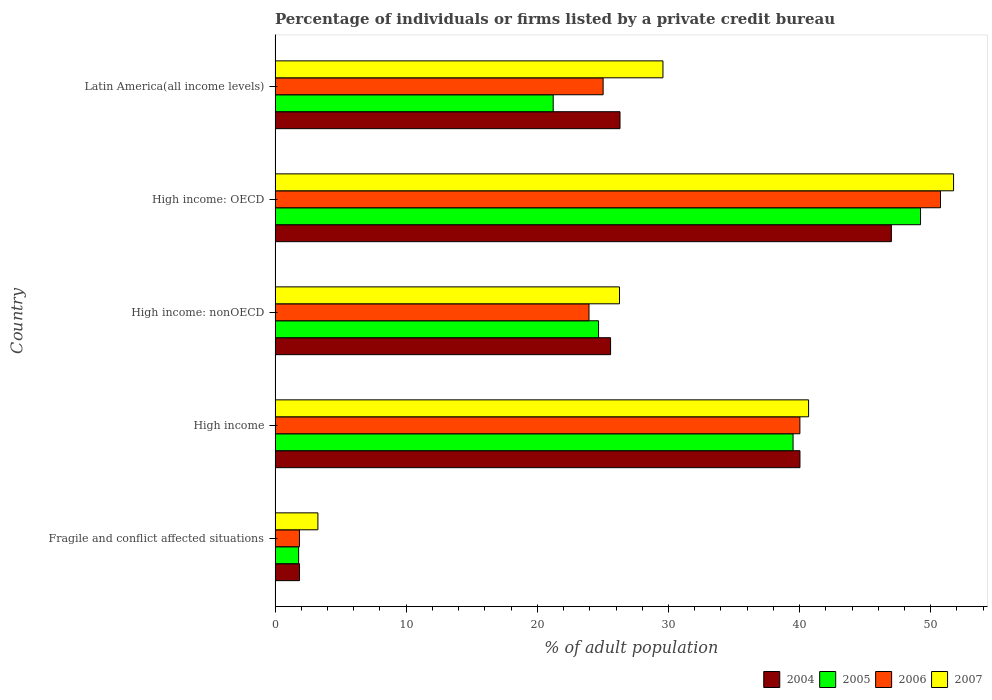What is the label of the 2nd group of bars from the top?
Make the answer very short. High income: OECD. In how many cases, is the number of bars for a given country not equal to the number of legend labels?
Keep it short and to the point. 0. What is the percentage of population listed by a private credit bureau in 2005 in Latin America(all income levels)?
Your answer should be compact. 21.21. Across all countries, what is the maximum percentage of population listed by a private credit bureau in 2006?
Offer a terse response. 50.75. Across all countries, what is the minimum percentage of population listed by a private credit bureau in 2004?
Your answer should be compact. 1.86. In which country was the percentage of population listed by a private credit bureau in 2004 maximum?
Ensure brevity in your answer.  High income: OECD. In which country was the percentage of population listed by a private credit bureau in 2006 minimum?
Give a very brief answer. Fragile and conflict affected situations. What is the total percentage of population listed by a private credit bureau in 2007 in the graph?
Offer a very short reply. 151.54. What is the difference between the percentage of population listed by a private credit bureau in 2005 in High income and that in High income: nonOECD?
Your answer should be very brief. 14.84. What is the difference between the percentage of population listed by a private credit bureau in 2004 in Latin America(all income levels) and the percentage of population listed by a private credit bureau in 2005 in High income: OECD?
Provide a succinct answer. -22.92. What is the average percentage of population listed by a private credit bureau in 2007 per country?
Make the answer very short. 30.31. What is the difference between the percentage of population listed by a private credit bureau in 2004 and percentage of population listed by a private credit bureau in 2005 in High income?
Give a very brief answer. 0.52. What is the ratio of the percentage of population listed by a private credit bureau in 2006 in High income: nonOECD to that in Latin America(all income levels)?
Your response must be concise. 0.96. Is the percentage of population listed by a private credit bureau in 2007 in Fragile and conflict affected situations less than that in High income: OECD?
Your answer should be compact. Yes. Is the difference between the percentage of population listed by a private credit bureau in 2004 in Fragile and conflict affected situations and Latin America(all income levels) greater than the difference between the percentage of population listed by a private credit bureau in 2005 in Fragile and conflict affected situations and Latin America(all income levels)?
Your answer should be very brief. No. What is the difference between the highest and the second highest percentage of population listed by a private credit bureau in 2005?
Keep it short and to the point. 9.72. What is the difference between the highest and the lowest percentage of population listed by a private credit bureau in 2004?
Provide a succinct answer. 45.14. In how many countries, is the percentage of population listed by a private credit bureau in 2005 greater than the average percentage of population listed by a private credit bureau in 2005 taken over all countries?
Ensure brevity in your answer.  2. Is the sum of the percentage of population listed by a private credit bureau in 2005 in High income: OECD and High income: nonOECD greater than the maximum percentage of population listed by a private credit bureau in 2007 across all countries?
Your response must be concise. Yes. Is it the case that in every country, the sum of the percentage of population listed by a private credit bureau in 2004 and percentage of population listed by a private credit bureau in 2005 is greater than the sum of percentage of population listed by a private credit bureau in 2006 and percentage of population listed by a private credit bureau in 2007?
Offer a terse response. No. What does the 3rd bar from the top in High income: OECD represents?
Your response must be concise. 2005. What does the 4th bar from the bottom in Latin America(all income levels) represents?
Provide a short and direct response. 2007. Are all the bars in the graph horizontal?
Your response must be concise. Yes. Does the graph contain any zero values?
Your answer should be compact. No. Does the graph contain grids?
Your answer should be compact. No. What is the title of the graph?
Your answer should be compact. Percentage of individuals or firms listed by a private credit bureau. Does "1998" appear as one of the legend labels in the graph?
Your answer should be very brief. No. What is the label or title of the X-axis?
Keep it short and to the point. % of adult population. What is the label or title of the Y-axis?
Offer a terse response. Country. What is the % of adult population in 2004 in Fragile and conflict affected situations?
Give a very brief answer. 1.86. What is the % of adult population in 2005 in Fragile and conflict affected situations?
Your answer should be compact. 1.8. What is the % of adult population in 2006 in Fragile and conflict affected situations?
Keep it short and to the point. 1.86. What is the % of adult population in 2007 in Fragile and conflict affected situations?
Offer a very short reply. 3.27. What is the % of adult population in 2004 in High income?
Make the answer very short. 40.03. What is the % of adult population of 2005 in High income?
Make the answer very short. 39.5. What is the % of adult population in 2006 in High income?
Keep it short and to the point. 40.02. What is the % of adult population of 2007 in High income?
Your answer should be compact. 40.69. What is the % of adult population in 2004 in High income: nonOECD?
Make the answer very short. 25.59. What is the % of adult population of 2005 in High income: nonOECD?
Make the answer very short. 24.67. What is the % of adult population of 2006 in High income: nonOECD?
Offer a terse response. 23.94. What is the % of adult population in 2007 in High income: nonOECD?
Offer a very short reply. 26.27. What is the % of adult population of 2005 in High income: OECD?
Provide a short and direct response. 49.22. What is the % of adult population in 2006 in High income: OECD?
Your response must be concise. 50.75. What is the % of adult population of 2007 in High income: OECD?
Your answer should be very brief. 51.74. What is the % of adult population in 2004 in Latin America(all income levels)?
Ensure brevity in your answer.  26.3. What is the % of adult population in 2005 in Latin America(all income levels)?
Make the answer very short. 21.21. What is the % of adult population of 2006 in Latin America(all income levels)?
Your answer should be very brief. 25.02. What is the % of adult population of 2007 in Latin America(all income levels)?
Offer a very short reply. 29.58. Across all countries, what is the maximum % of adult population of 2005?
Keep it short and to the point. 49.22. Across all countries, what is the maximum % of adult population in 2006?
Provide a short and direct response. 50.75. Across all countries, what is the maximum % of adult population in 2007?
Your answer should be compact. 51.74. Across all countries, what is the minimum % of adult population of 2004?
Provide a short and direct response. 1.86. Across all countries, what is the minimum % of adult population of 2005?
Offer a terse response. 1.8. Across all countries, what is the minimum % of adult population in 2006?
Your answer should be very brief. 1.86. Across all countries, what is the minimum % of adult population of 2007?
Your answer should be compact. 3.27. What is the total % of adult population in 2004 in the graph?
Offer a very short reply. 140.78. What is the total % of adult population in 2005 in the graph?
Keep it short and to the point. 136.4. What is the total % of adult population of 2006 in the graph?
Provide a short and direct response. 141.59. What is the total % of adult population of 2007 in the graph?
Keep it short and to the point. 151.54. What is the difference between the % of adult population in 2004 in Fragile and conflict affected situations and that in High income?
Your answer should be very brief. -38.16. What is the difference between the % of adult population in 2005 in Fragile and conflict affected situations and that in High income?
Provide a succinct answer. -37.71. What is the difference between the % of adult population in 2006 in Fragile and conflict affected situations and that in High income?
Offer a terse response. -38.17. What is the difference between the % of adult population in 2007 in Fragile and conflict affected situations and that in High income?
Offer a terse response. -37.42. What is the difference between the % of adult population of 2004 in Fragile and conflict affected situations and that in High income: nonOECD?
Your answer should be very brief. -23.72. What is the difference between the % of adult population of 2005 in Fragile and conflict affected situations and that in High income: nonOECD?
Your response must be concise. -22.87. What is the difference between the % of adult population of 2006 in Fragile and conflict affected situations and that in High income: nonOECD?
Offer a very short reply. -22.08. What is the difference between the % of adult population in 2007 in Fragile and conflict affected situations and that in High income: nonOECD?
Give a very brief answer. -23. What is the difference between the % of adult population in 2004 in Fragile and conflict affected situations and that in High income: OECD?
Your answer should be compact. -45.14. What is the difference between the % of adult population of 2005 in Fragile and conflict affected situations and that in High income: OECD?
Provide a short and direct response. -47.43. What is the difference between the % of adult population in 2006 in Fragile and conflict affected situations and that in High income: OECD?
Provide a short and direct response. -48.89. What is the difference between the % of adult population in 2007 in Fragile and conflict affected situations and that in High income: OECD?
Your answer should be compact. -48.48. What is the difference between the % of adult population of 2004 in Fragile and conflict affected situations and that in Latin America(all income levels)?
Provide a succinct answer. -24.44. What is the difference between the % of adult population in 2005 in Fragile and conflict affected situations and that in Latin America(all income levels)?
Your response must be concise. -19.41. What is the difference between the % of adult population of 2006 in Fragile and conflict affected situations and that in Latin America(all income levels)?
Offer a very short reply. -23.16. What is the difference between the % of adult population of 2007 in Fragile and conflict affected situations and that in Latin America(all income levels)?
Keep it short and to the point. -26.31. What is the difference between the % of adult population in 2004 in High income and that in High income: nonOECD?
Provide a short and direct response. 14.44. What is the difference between the % of adult population in 2005 in High income and that in High income: nonOECD?
Your answer should be very brief. 14.84. What is the difference between the % of adult population in 2006 in High income and that in High income: nonOECD?
Make the answer very short. 16.08. What is the difference between the % of adult population in 2007 in High income and that in High income: nonOECD?
Ensure brevity in your answer.  14.42. What is the difference between the % of adult population of 2004 in High income and that in High income: OECD?
Provide a short and direct response. -6.97. What is the difference between the % of adult population of 2005 in High income and that in High income: OECD?
Ensure brevity in your answer.  -9.72. What is the difference between the % of adult population in 2006 in High income and that in High income: OECD?
Give a very brief answer. -10.72. What is the difference between the % of adult population of 2007 in High income and that in High income: OECD?
Provide a succinct answer. -11.06. What is the difference between the % of adult population in 2004 in High income and that in Latin America(all income levels)?
Your answer should be compact. 13.72. What is the difference between the % of adult population of 2005 in High income and that in Latin America(all income levels)?
Your answer should be very brief. 18.29. What is the difference between the % of adult population of 2006 in High income and that in Latin America(all income levels)?
Ensure brevity in your answer.  15.01. What is the difference between the % of adult population in 2007 in High income and that in Latin America(all income levels)?
Your answer should be very brief. 11.11. What is the difference between the % of adult population in 2004 in High income: nonOECD and that in High income: OECD?
Make the answer very short. -21.41. What is the difference between the % of adult population in 2005 in High income: nonOECD and that in High income: OECD?
Provide a short and direct response. -24.56. What is the difference between the % of adult population of 2006 in High income: nonOECD and that in High income: OECD?
Make the answer very short. -26.81. What is the difference between the % of adult population of 2007 in High income: nonOECD and that in High income: OECD?
Your answer should be very brief. -25.48. What is the difference between the % of adult population in 2004 in High income: nonOECD and that in Latin America(all income levels)?
Your answer should be very brief. -0.72. What is the difference between the % of adult population in 2005 in High income: nonOECD and that in Latin America(all income levels)?
Offer a terse response. 3.46. What is the difference between the % of adult population of 2006 in High income: nonOECD and that in Latin America(all income levels)?
Give a very brief answer. -1.08. What is the difference between the % of adult population in 2007 in High income: nonOECD and that in Latin America(all income levels)?
Make the answer very short. -3.31. What is the difference between the % of adult population of 2004 in High income: OECD and that in Latin America(all income levels)?
Make the answer very short. 20.7. What is the difference between the % of adult population of 2005 in High income: OECD and that in Latin America(all income levels)?
Give a very brief answer. 28.01. What is the difference between the % of adult population in 2006 in High income: OECD and that in Latin America(all income levels)?
Provide a succinct answer. 25.73. What is the difference between the % of adult population of 2007 in High income: OECD and that in Latin America(all income levels)?
Your answer should be very brief. 22.16. What is the difference between the % of adult population of 2004 in Fragile and conflict affected situations and the % of adult population of 2005 in High income?
Your response must be concise. -37.64. What is the difference between the % of adult population in 2004 in Fragile and conflict affected situations and the % of adult population in 2006 in High income?
Keep it short and to the point. -38.16. What is the difference between the % of adult population in 2004 in Fragile and conflict affected situations and the % of adult population in 2007 in High income?
Your answer should be very brief. -38.82. What is the difference between the % of adult population of 2005 in Fragile and conflict affected situations and the % of adult population of 2006 in High income?
Keep it short and to the point. -38.23. What is the difference between the % of adult population in 2005 in Fragile and conflict affected situations and the % of adult population in 2007 in High income?
Provide a short and direct response. -38.89. What is the difference between the % of adult population in 2006 in Fragile and conflict affected situations and the % of adult population in 2007 in High income?
Your answer should be very brief. -38.83. What is the difference between the % of adult population in 2004 in Fragile and conflict affected situations and the % of adult population in 2005 in High income: nonOECD?
Your answer should be compact. -22.8. What is the difference between the % of adult population in 2004 in Fragile and conflict affected situations and the % of adult population in 2006 in High income: nonOECD?
Make the answer very short. -22.08. What is the difference between the % of adult population in 2004 in Fragile and conflict affected situations and the % of adult population in 2007 in High income: nonOECD?
Your answer should be very brief. -24.4. What is the difference between the % of adult population in 2005 in Fragile and conflict affected situations and the % of adult population in 2006 in High income: nonOECD?
Provide a succinct answer. -22.14. What is the difference between the % of adult population of 2005 in Fragile and conflict affected situations and the % of adult population of 2007 in High income: nonOECD?
Make the answer very short. -24.47. What is the difference between the % of adult population of 2006 in Fragile and conflict affected situations and the % of adult population of 2007 in High income: nonOECD?
Keep it short and to the point. -24.41. What is the difference between the % of adult population in 2004 in Fragile and conflict affected situations and the % of adult population in 2005 in High income: OECD?
Keep it short and to the point. -47.36. What is the difference between the % of adult population of 2004 in Fragile and conflict affected situations and the % of adult population of 2006 in High income: OECD?
Provide a succinct answer. -48.88. What is the difference between the % of adult population of 2004 in Fragile and conflict affected situations and the % of adult population of 2007 in High income: OECD?
Your response must be concise. -49.88. What is the difference between the % of adult population of 2005 in Fragile and conflict affected situations and the % of adult population of 2006 in High income: OECD?
Offer a very short reply. -48.95. What is the difference between the % of adult population of 2005 in Fragile and conflict affected situations and the % of adult population of 2007 in High income: OECD?
Provide a succinct answer. -49.95. What is the difference between the % of adult population in 2006 in Fragile and conflict affected situations and the % of adult population in 2007 in High income: OECD?
Your answer should be very brief. -49.88. What is the difference between the % of adult population in 2004 in Fragile and conflict affected situations and the % of adult population in 2005 in Latin America(all income levels)?
Provide a short and direct response. -19.35. What is the difference between the % of adult population in 2004 in Fragile and conflict affected situations and the % of adult population in 2006 in Latin America(all income levels)?
Your answer should be very brief. -23.15. What is the difference between the % of adult population of 2004 in Fragile and conflict affected situations and the % of adult population of 2007 in Latin America(all income levels)?
Offer a terse response. -27.72. What is the difference between the % of adult population in 2005 in Fragile and conflict affected situations and the % of adult population in 2006 in Latin America(all income levels)?
Ensure brevity in your answer.  -23.22. What is the difference between the % of adult population in 2005 in Fragile and conflict affected situations and the % of adult population in 2007 in Latin America(all income levels)?
Ensure brevity in your answer.  -27.78. What is the difference between the % of adult population of 2006 in Fragile and conflict affected situations and the % of adult population of 2007 in Latin America(all income levels)?
Keep it short and to the point. -27.72. What is the difference between the % of adult population in 2004 in High income and the % of adult population in 2005 in High income: nonOECD?
Keep it short and to the point. 15.36. What is the difference between the % of adult population in 2004 in High income and the % of adult population in 2006 in High income: nonOECD?
Your response must be concise. 16.09. What is the difference between the % of adult population of 2004 in High income and the % of adult population of 2007 in High income: nonOECD?
Keep it short and to the point. 13.76. What is the difference between the % of adult population of 2005 in High income and the % of adult population of 2006 in High income: nonOECD?
Make the answer very short. 15.56. What is the difference between the % of adult population in 2005 in High income and the % of adult population in 2007 in High income: nonOECD?
Provide a short and direct response. 13.24. What is the difference between the % of adult population of 2006 in High income and the % of adult population of 2007 in High income: nonOECD?
Provide a succinct answer. 13.76. What is the difference between the % of adult population of 2004 in High income and the % of adult population of 2005 in High income: OECD?
Provide a succinct answer. -9.2. What is the difference between the % of adult population of 2004 in High income and the % of adult population of 2006 in High income: OECD?
Make the answer very short. -10.72. What is the difference between the % of adult population of 2004 in High income and the % of adult population of 2007 in High income: OECD?
Provide a succinct answer. -11.72. What is the difference between the % of adult population of 2005 in High income and the % of adult population of 2006 in High income: OECD?
Provide a short and direct response. -11.24. What is the difference between the % of adult population of 2005 in High income and the % of adult population of 2007 in High income: OECD?
Provide a succinct answer. -12.24. What is the difference between the % of adult population in 2006 in High income and the % of adult population in 2007 in High income: OECD?
Provide a succinct answer. -11.72. What is the difference between the % of adult population in 2004 in High income and the % of adult population in 2005 in Latin America(all income levels)?
Make the answer very short. 18.82. What is the difference between the % of adult population of 2004 in High income and the % of adult population of 2006 in Latin America(all income levels)?
Your answer should be compact. 15.01. What is the difference between the % of adult population of 2004 in High income and the % of adult population of 2007 in Latin America(all income levels)?
Provide a succinct answer. 10.45. What is the difference between the % of adult population of 2005 in High income and the % of adult population of 2006 in Latin America(all income levels)?
Ensure brevity in your answer.  14.49. What is the difference between the % of adult population of 2005 in High income and the % of adult population of 2007 in Latin America(all income levels)?
Your answer should be compact. 9.92. What is the difference between the % of adult population of 2006 in High income and the % of adult population of 2007 in Latin America(all income levels)?
Your response must be concise. 10.44. What is the difference between the % of adult population of 2004 in High income: nonOECD and the % of adult population of 2005 in High income: OECD?
Make the answer very short. -23.64. What is the difference between the % of adult population of 2004 in High income: nonOECD and the % of adult population of 2006 in High income: OECD?
Make the answer very short. -25.16. What is the difference between the % of adult population of 2004 in High income: nonOECD and the % of adult population of 2007 in High income: OECD?
Your answer should be very brief. -26.16. What is the difference between the % of adult population of 2005 in High income: nonOECD and the % of adult population of 2006 in High income: OECD?
Ensure brevity in your answer.  -26.08. What is the difference between the % of adult population of 2005 in High income: nonOECD and the % of adult population of 2007 in High income: OECD?
Your response must be concise. -27.07. What is the difference between the % of adult population of 2006 in High income: nonOECD and the % of adult population of 2007 in High income: OECD?
Provide a succinct answer. -27.8. What is the difference between the % of adult population in 2004 in High income: nonOECD and the % of adult population in 2005 in Latin America(all income levels)?
Offer a terse response. 4.38. What is the difference between the % of adult population of 2004 in High income: nonOECD and the % of adult population of 2006 in Latin America(all income levels)?
Make the answer very short. 0.57. What is the difference between the % of adult population of 2004 in High income: nonOECD and the % of adult population of 2007 in Latin America(all income levels)?
Provide a succinct answer. -3.99. What is the difference between the % of adult population in 2005 in High income: nonOECD and the % of adult population in 2006 in Latin America(all income levels)?
Keep it short and to the point. -0.35. What is the difference between the % of adult population of 2005 in High income: nonOECD and the % of adult population of 2007 in Latin America(all income levels)?
Keep it short and to the point. -4.91. What is the difference between the % of adult population in 2006 in High income: nonOECD and the % of adult population in 2007 in Latin America(all income levels)?
Your response must be concise. -5.64. What is the difference between the % of adult population of 2004 in High income: OECD and the % of adult population of 2005 in Latin America(all income levels)?
Give a very brief answer. 25.79. What is the difference between the % of adult population in 2004 in High income: OECD and the % of adult population in 2006 in Latin America(all income levels)?
Provide a succinct answer. 21.98. What is the difference between the % of adult population in 2004 in High income: OECD and the % of adult population in 2007 in Latin America(all income levels)?
Provide a short and direct response. 17.42. What is the difference between the % of adult population of 2005 in High income: OECD and the % of adult population of 2006 in Latin America(all income levels)?
Your answer should be compact. 24.21. What is the difference between the % of adult population of 2005 in High income: OECD and the % of adult population of 2007 in Latin America(all income levels)?
Offer a very short reply. 19.64. What is the difference between the % of adult population of 2006 in High income: OECD and the % of adult population of 2007 in Latin America(all income levels)?
Provide a succinct answer. 21.17. What is the average % of adult population in 2004 per country?
Make the answer very short. 28.16. What is the average % of adult population of 2005 per country?
Your answer should be compact. 27.28. What is the average % of adult population in 2006 per country?
Your response must be concise. 28.32. What is the average % of adult population in 2007 per country?
Give a very brief answer. 30.31. What is the difference between the % of adult population of 2004 and % of adult population of 2005 in Fragile and conflict affected situations?
Make the answer very short. 0.07. What is the difference between the % of adult population in 2004 and % of adult population in 2006 in Fragile and conflict affected situations?
Make the answer very short. 0.01. What is the difference between the % of adult population of 2004 and % of adult population of 2007 in Fragile and conflict affected situations?
Your response must be concise. -1.4. What is the difference between the % of adult population of 2005 and % of adult population of 2006 in Fragile and conflict affected situations?
Your answer should be very brief. -0.06. What is the difference between the % of adult population in 2005 and % of adult population in 2007 in Fragile and conflict affected situations?
Give a very brief answer. -1.47. What is the difference between the % of adult population of 2006 and % of adult population of 2007 in Fragile and conflict affected situations?
Give a very brief answer. -1.41. What is the difference between the % of adult population of 2004 and % of adult population of 2005 in High income?
Offer a terse response. 0.52. What is the difference between the % of adult population of 2004 and % of adult population of 2006 in High income?
Provide a succinct answer. 0. What is the difference between the % of adult population of 2004 and % of adult population of 2007 in High income?
Ensure brevity in your answer.  -0.66. What is the difference between the % of adult population in 2005 and % of adult population in 2006 in High income?
Provide a succinct answer. -0.52. What is the difference between the % of adult population in 2005 and % of adult population in 2007 in High income?
Give a very brief answer. -1.18. What is the difference between the % of adult population in 2006 and % of adult population in 2007 in High income?
Offer a very short reply. -0.66. What is the difference between the % of adult population in 2004 and % of adult population in 2005 in High income: nonOECD?
Provide a succinct answer. 0.92. What is the difference between the % of adult population in 2004 and % of adult population in 2006 in High income: nonOECD?
Ensure brevity in your answer.  1.65. What is the difference between the % of adult population of 2004 and % of adult population of 2007 in High income: nonOECD?
Make the answer very short. -0.68. What is the difference between the % of adult population of 2005 and % of adult population of 2006 in High income: nonOECD?
Your answer should be very brief. 0.73. What is the difference between the % of adult population in 2005 and % of adult population in 2007 in High income: nonOECD?
Your response must be concise. -1.6. What is the difference between the % of adult population in 2006 and % of adult population in 2007 in High income: nonOECD?
Keep it short and to the point. -2.33. What is the difference between the % of adult population in 2004 and % of adult population in 2005 in High income: OECD?
Ensure brevity in your answer.  -2.22. What is the difference between the % of adult population in 2004 and % of adult population in 2006 in High income: OECD?
Your answer should be very brief. -3.75. What is the difference between the % of adult population in 2004 and % of adult population in 2007 in High income: OECD?
Make the answer very short. -4.74. What is the difference between the % of adult population in 2005 and % of adult population in 2006 in High income: OECD?
Offer a terse response. -1.52. What is the difference between the % of adult population of 2005 and % of adult population of 2007 in High income: OECD?
Your answer should be compact. -2.52. What is the difference between the % of adult population of 2006 and % of adult population of 2007 in High income: OECD?
Provide a succinct answer. -1. What is the difference between the % of adult population of 2004 and % of adult population of 2005 in Latin America(all income levels)?
Give a very brief answer. 5.09. What is the difference between the % of adult population of 2004 and % of adult population of 2006 in Latin America(all income levels)?
Give a very brief answer. 1.29. What is the difference between the % of adult population in 2004 and % of adult population in 2007 in Latin America(all income levels)?
Ensure brevity in your answer.  -3.27. What is the difference between the % of adult population in 2005 and % of adult population in 2006 in Latin America(all income levels)?
Provide a short and direct response. -3.81. What is the difference between the % of adult population in 2005 and % of adult population in 2007 in Latin America(all income levels)?
Offer a very short reply. -8.37. What is the difference between the % of adult population of 2006 and % of adult population of 2007 in Latin America(all income levels)?
Your response must be concise. -4.56. What is the ratio of the % of adult population of 2004 in Fragile and conflict affected situations to that in High income?
Provide a succinct answer. 0.05. What is the ratio of the % of adult population in 2005 in Fragile and conflict affected situations to that in High income?
Give a very brief answer. 0.05. What is the ratio of the % of adult population in 2006 in Fragile and conflict affected situations to that in High income?
Provide a succinct answer. 0.05. What is the ratio of the % of adult population in 2007 in Fragile and conflict affected situations to that in High income?
Give a very brief answer. 0.08. What is the ratio of the % of adult population in 2004 in Fragile and conflict affected situations to that in High income: nonOECD?
Provide a short and direct response. 0.07. What is the ratio of the % of adult population in 2005 in Fragile and conflict affected situations to that in High income: nonOECD?
Your answer should be very brief. 0.07. What is the ratio of the % of adult population of 2006 in Fragile and conflict affected situations to that in High income: nonOECD?
Your response must be concise. 0.08. What is the ratio of the % of adult population of 2007 in Fragile and conflict affected situations to that in High income: nonOECD?
Keep it short and to the point. 0.12. What is the ratio of the % of adult population in 2004 in Fragile and conflict affected situations to that in High income: OECD?
Offer a terse response. 0.04. What is the ratio of the % of adult population of 2005 in Fragile and conflict affected situations to that in High income: OECD?
Make the answer very short. 0.04. What is the ratio of the % of adult population of 2006 in Fragile and conflict affected situations to that in High income: OECD?
Your answer should be compact. 0.04. What is the ratio of the % of adult population of 2007 in Fragile and conflict affected situations to that in High income: OECD?
Provide a short and direct response. 0.06. What is the ratio of the % of adult population of 2004 in Fragile and conflict affected situations to that in Latin America(all income levels)?
Provide a short and direct response. 0.07. What is the ratio of the % of adult population in 2005 in Fragile and conflict affected situations to that in Latin America(all income levels)?
Your answer should be very brief. 0.08. What is the ratio of the % of adult population in 2006 in Fragile and conflict affected situations to that in Latin America(all income levels)?
Provide a succinct answer. 0.07. What is the ratio of the % of adult population of 2007 in Fragile and conflict affected situations to that in Latin America(all income levels)?
Keep it short and to the point. 0.11. What is the ratio of the % of adult population of 2004 in High income to that in High income: nonOECD?
Offer a terse response. 1.56. What is the ratio of the % of adult population in 2005 in High income to that in High income: nonOECD?
Ensure brevity in your answer.  1.6. What is the ratio of the % of adult population of 2006 in High income to that in High income: nonOECD?
Provide a succinct answer. 1.67. What is the ratio of the % of adult population of 2007 in High income to that in High income: nonOECD?
Make the answer very short. 1.55. What is the ratio of the % of adult population of 2004 in High income to that in High income: OECD?
Provide a succinct answer. 0.85. What is the ratio of the % of adult population of 2005 in High income to that in High income: OECD?
Provide a short and direct response. 0.8. What is the ratio of the % of adult population of 2006 in High income to that in High income: OECD?
Your answer should be compact. 0.79. What is the ratio of the % of adult population in 2007 in High income to that in High income: OECD?
Ensure brevity in your answer.  0.79. What is the ratio of the % of adult population in 2004 in High income to that in Latin America(all income levels)?
Your answer should be compact. 1.52. What is the ratio of the % of adult population in 2005 in High income to that in Latin America(all income levels)?
Provide a short and direct response. 1.86. What is the ratio of the % of adult population of 2006 in High income to that in Latin America(all income levels)?
Your response must be concise. 1.6. What is the ratio of the % of adult population of 2007 in High income to that in Latin America(all income levels)?
Your answer should be compact. 1.38. What is the ratio of the % of adult population of 2004 in High income: nonOECD to that in High income: OECD?
Keep it short and to the point. 0.54. What is the ratio of the % of adult population of 2005 in High income: nonOECD to that in High income: OECD?
Provide a short and direct response. 0.5. What is the ratio of the % of adult population in 2006 in High income: nonOECD to that in High income: OECD?
Give a very brief answer. 0.47. What is the ratio of the % of adult population of 2007 in High income: nonOECD to that in High income: OECD?
Make the answer very short. 0.51. What is the ratio of the % of adult population in 2004 in High income: nonOECD to that in Latin America(all income levels)?
Ensure brevity in your answer.  0.97. What is the ratio of the % of adult population of 2005 in High income: nonOECD to that in Latin America(all income levels)?
Provide a short and direct response. 1.16. What is the ratio of the % of adult population in 2006 in High income: nonOECD to that in Latin America(all income levels)?
Your response must be concise. 0.96. What is the ratio of the % of adult population of 2007 in High income: nonOECD to that in Latin America(all income levels)?
Your answer should be compact. 0.89. What is the ratio of the % of adult population of 2004 in High income: OECD to that in Latin America(all income levels)?
Keep it short and to the point. 1.79. What is the ratio of the % of adult population in 2005 in High income: OECD to that in Latin America(all income levels)?
Keep it short and to the point. 2.32. What is the ratio of the % of adult population of 2006 in High income: OECD to that in Latin America(all income levels)?
Offer a terse response. 2.03. What is the ratio of the % of adult population in 2007 in High income: OECD to that in Latin America(all income levels)?
Provide a succinct answer. 1.75. What is the difference between the highest and the second highest % of adult population in 2004?
Offer a very short reply. 6.97. What is the difference between the highest and the second highest % of adult population of 2005?
Make the answer very short. 9.72. What is the difference between the highest and the second highest % of adult population of 2006?
Offer a very short reply. 10.72. What is the difference between the highest and the second highest % of adult population of 2007?
Ensure brevity in your answer.  11.06. What is the difference between the highest and the lowest % of adult population of 2004?
Give a very brief answer. 45.14. What is the difference between the highest and the lowest % of adult population in 2005?
Your response must be concise. 47.43. What is the difference between the highest and the lowest % of adult population of 2006?
Keep it short and to the point. 48.89. What is the difference between the highest and the lowest % of adult population in 2007?
Offer a terse response. 48.48. 